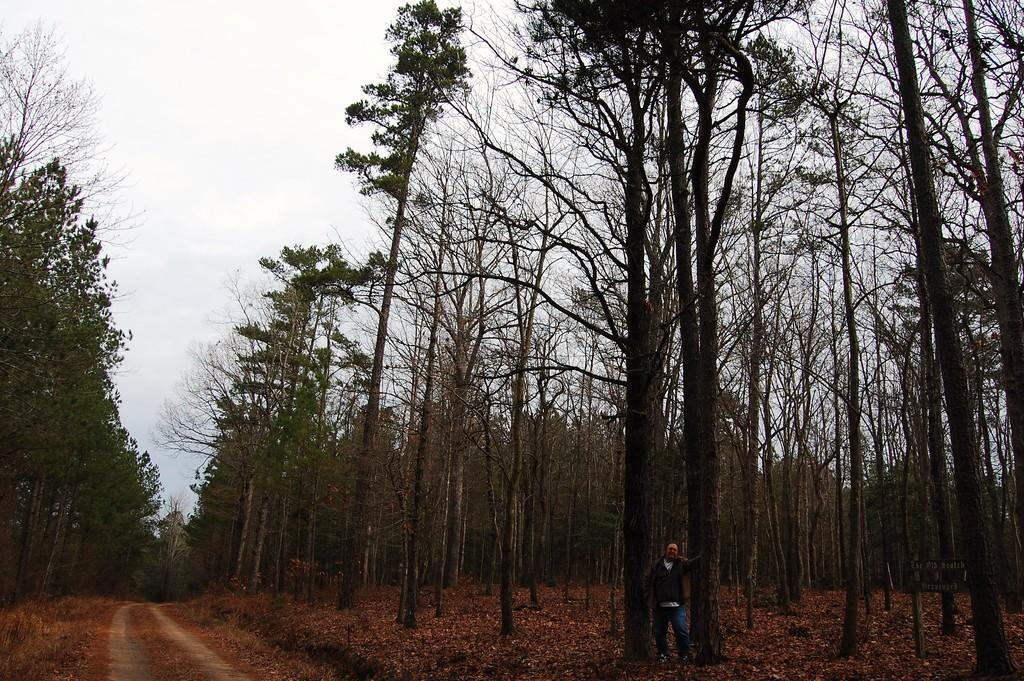What type of vegetation can be seen in the image? There are trees with branches and leaves in the image. Can you describe the person in the image? There is a person standing in the image. What kind of surface is visible in the image? It appears to be a pathway in the image. What is present on the ground in the image? There are dried leaves lying on the ground in the image. What can be seen in the sky in the image? The sky is visible in the image. How does the person support the bubble in the image? There is no bubble present in the image, so the person is not supporting any bubble. What type of twist can be seen in the branches of the trees in the image? The branches of the trees in the image do not show any specific twist; they are simply branches with leaves. 